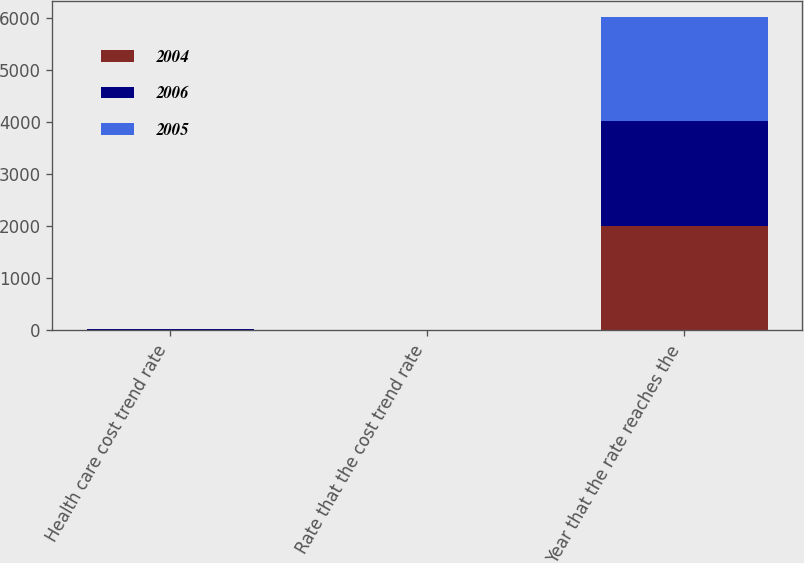<chart> <loc_0><loc_0><loc_500><loc_500><stacked_bar_chart><ecel><fcel>Health care cost trend rate<fcel>Rate that the cost trend rate<fcel>Year that the rate reaches the<nl><fcel>2004<fcel>10<fcel>5<fcel>2011<nl><fcel>2006<fcel>10<fcel>5<fcel>2010<nl><fcel>2005<fcel>10<fcel>5<fcel>2009<nl></chart> 